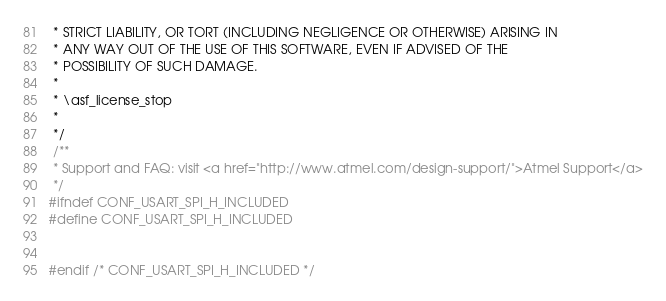<code> <loc_0><loc_0><loc_500><loc_500><_C_> * STRICT LIABILITY, OR TORT (INCLUDING NEGLIGENCE OR OTHERWISE) ARISING IN
 * ANY WAY OUT OF THE USE OF THIS SOFTWARE, EVEN IF ADVISED OF THE
 * POSSIBILITY OF SUCH DAMAGE.
 *
 * \asf_license_stop
 *
 */
 /**
 * Support and FAQ: visit <a href="http://www.atmel.com/design-support/">Atmel Support</a>
 */
#ifndef CONF_USART_SPI_H_INCLUDED
#define CONF_USART_SPI_H_INCLUDED


#endif /* CONF_USART_SPI_H_INCLUDED */
</code> 